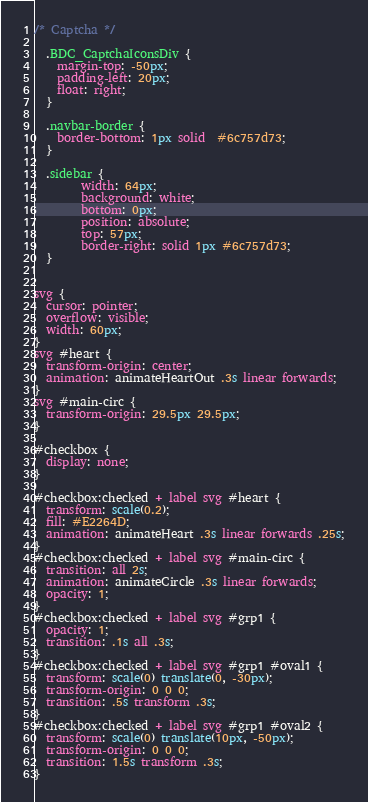Convert code to text. <code><loc_0><loc_0><loc_500><loc_500><_CSS_>
/* Captcha */

  .BDC_CaptchaIconsDiv {
    margin-top: -50px;
    padding-left: 20px;
    float: right;
  }

  .navbar-border {
    border-bottom: 1px solid  #6c757d73;
  }

  .sidebar {
        width: 64px;
        background: white;
        bottom: 0px;
        position: absolute;
        top: 57px;
        border-right: solid 1px #6c757d73;
  }


svg {
  cursor: pointer;
  overflow: visible;
  width: 60px;
}
svg #heart {
  transform-origin: center;
  animation: animateHeartOut .3s linear forwards;
}
svg #main-circ {
  transform-origin: 29.5px 29.5px;
}

#checkbox {
  display: none;
}

#checkbox:checked + label svg #heart {
  transform: scale(0.2);
  fill: #E2264D;
  animation: animateHeart .3s linear forwards .25s;
}
#checkbox:checked + label svg #main-circ {
  transition: all 2s;
  animation: animateCircle .3s linear forwards;
  opacity: 1;
}
#checkbox:checked + label svg #grp1 {
  opacity: 1;
  transition: .1s all .3s;
}
#checkbox:checked + label svg #grp1 #oval1 {
  transform: scale(0) translate(0, -30px);
  transform-origin: 0 0 0;
  transition: .5s transform .3s;
}
#checkbox:checked + label svg #grp1 #oval2 {
  transform: scale(0) translate(10px, -50px);
  transform-origin: 0 0 0;
  transition: 1.5s transform .3s;
}</code> 